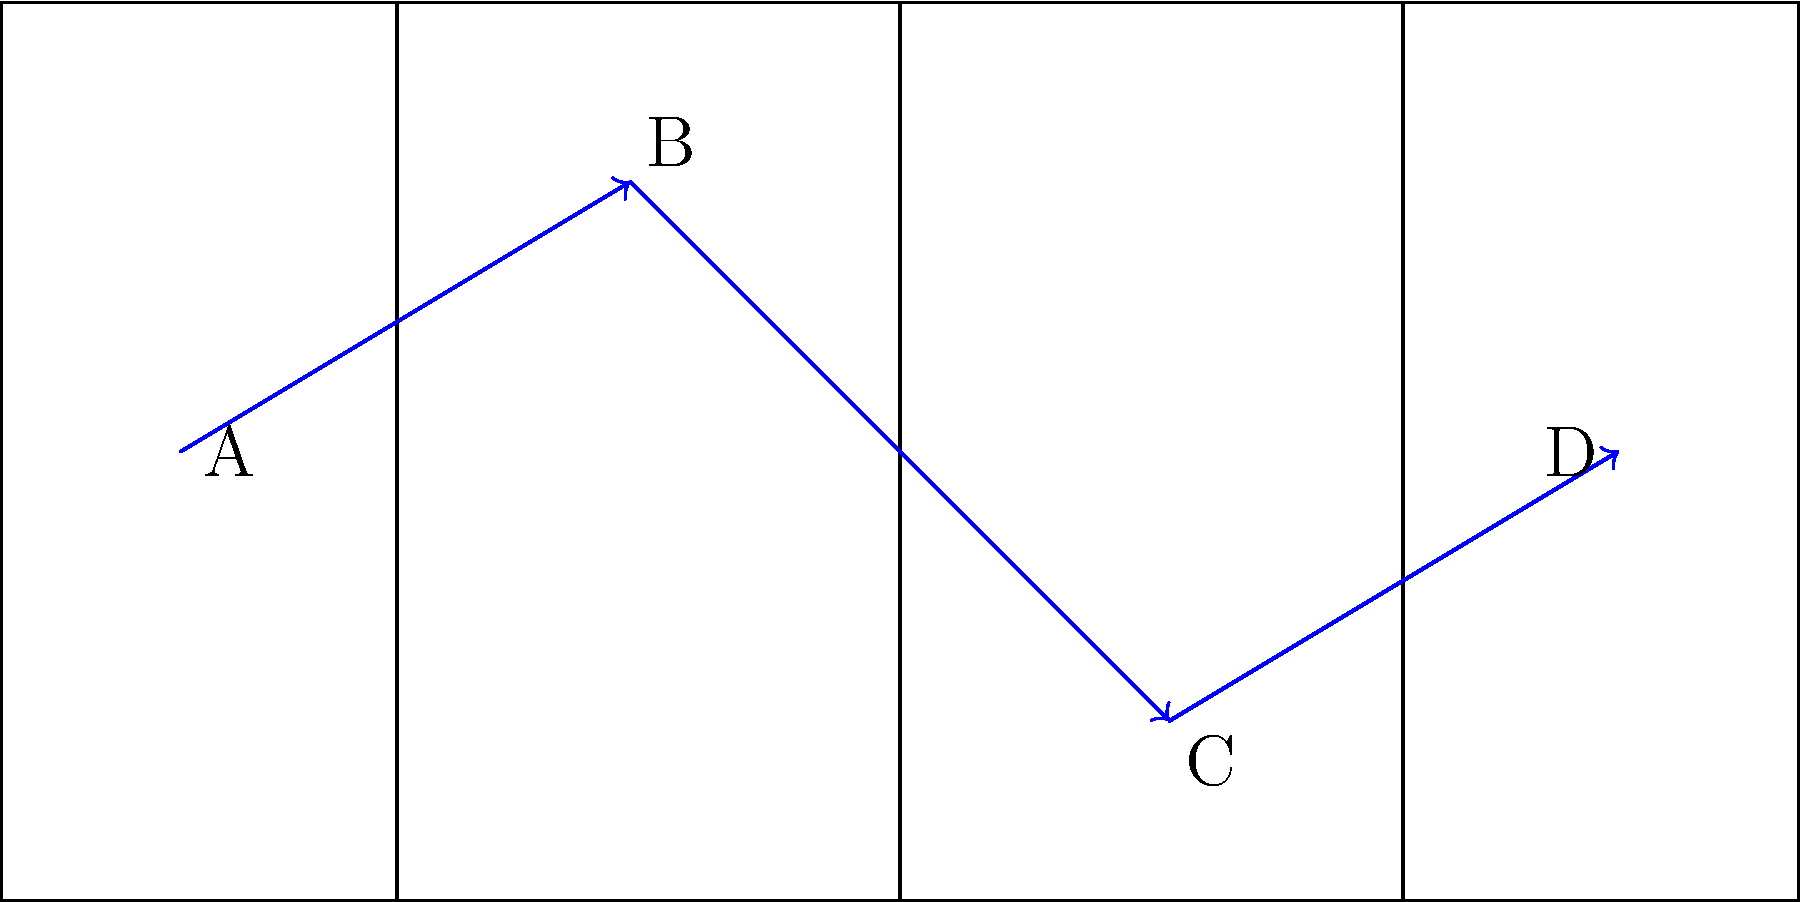In a crucial match, Tyler Dupree demonstrates his versatility by moving through different positions on the field. The diagram shows his strategic positioning in three phases of play, marked A, B, C, and D. Which sequence of positions best describes Tyler's role progression throughout the game, and how does this showcase his adaptability? To answer this question, we need to analyze Tyler Dupree's movements on the field and understand the roles associated with each position:

1. Position A (-40, 0): This is close to the try line on the left side of the field. This position is typically associated with a defensive role, possibly as a prop or lock in the forward pack.

2. Position B (-15, 15): Moving towards the center and slightly forward, this position could represent a flanker or number 8 role, allowing for both defensive cover and attacking support.

3. Position C (15, -15): Crossing the halfway line and moving to the opposite side of the field, this position suggests a more active role in attack, possibly as a center or wing.

4. Position D (40, 0): Near the opponent's try line, this position is ideal for scoring opportunities, typical of a winger or fullback in attack.

The progression A → B → C → D showcases Tyler's adaptability by demonstrating his ability to:

1. Start in a defensive position, likely in the forward pack.
2. Transition to a more versatile role, balancing defense and attack.
3. Move into the backline to participate in offensive plays.
4. Finish in a scoring position, capitalizing on attacking opportunities.

This sequence highlights Tyler's comprehensive skill set, allowing him to contribute effectively in various phases of play and adapt to the changing dynamics of the game.
Answer: Prop/Lock → Flanker/No.8 → Center/Wing → Winger/Fullback 